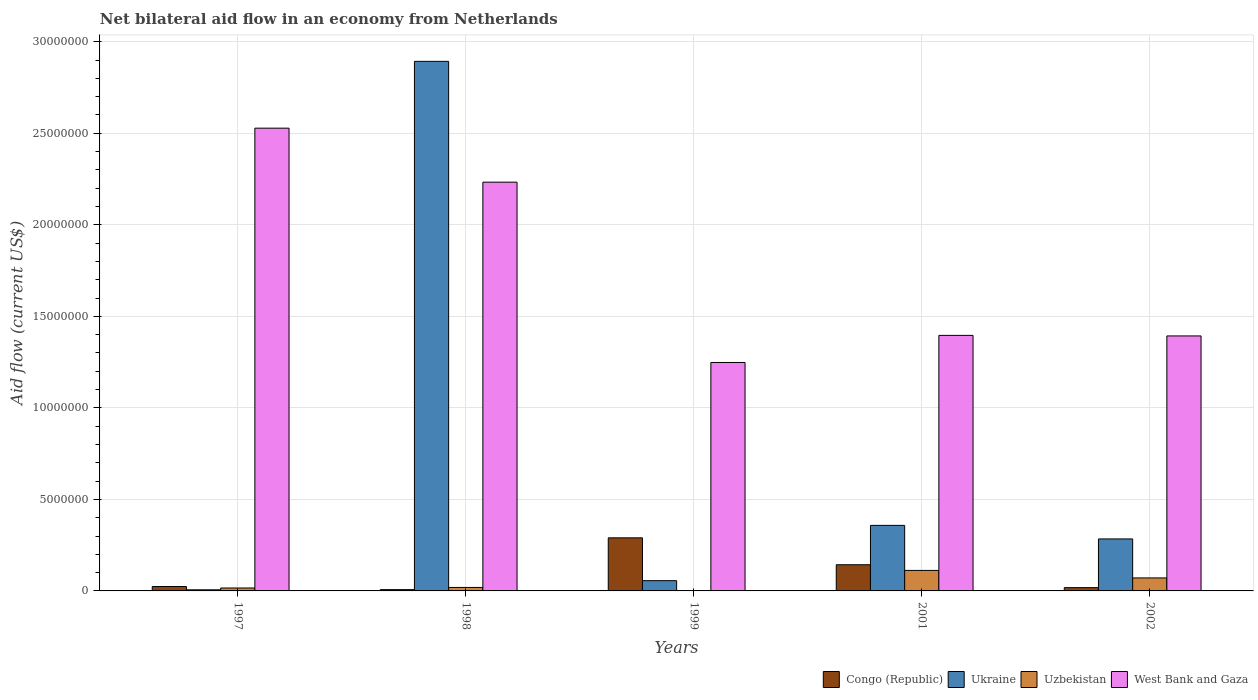How many different coloured bars are there?
Make the answer very short. 4. How many bars are there on the 1st tick from the left?
Provide a succinct answer. 4. How many bars are there on the 4th tick from the right?
Your answer should be very brief. 4. In how many cases, is the number of bars for a given year not equal to the number of legend labels?
Offer a terse response. 0. What is the net bilateral aid flow in West Bank and Gaza in 1998?
Give a very brief answer. 2.23e+07. Across all years, what is the maximum net bilateral aid flow in West Bank and Gaza?
Make the answer very short. 2.53e+07. In which year was the net bilateral aid flow in Ukraine maximum?
Provide a succinct answer. 1998. In which year was the net bilateral aid flow in Congo (Republic) minimum?
Give a very brief answer. 1998. What is the total net bilateral aid flow in Ukraine in the graph?
Your answer should be very brief. 3.60e+07. What is the difference between the net bilateral aid flow in Uzbekistan in 2001 and that in 2002?
Ensure brevity in your answer.  4.10e+05. What is the difference between the net bilateral aid flow in Congo (Republic) in 1998 and the net bilateral aid flow in Uzbekistan in 1999?
Give a very brief answer. 6.00e+04. What is the average net bilateral aid flow in Uzbekistan per year?
Make the answer very short. 4.38e+05. In the year 2002, what is the difference between the net bilateral aid flow in Ukraine and net bilateral aid flow in Congo (Republic)?
Offer a terse response. 2.66e+06. What is the ratio of the net bilateral aid flow in West Bank and Gaza in 1997 to that in 2001?
Offer a very short reply. 1.81. Is the difference between the net bilateral aid flow in Ukraine in 1998 and 1999 greater than the difference between the net bilateral aid flow in Congo (Republic) in 1998 and 1999?
Your answer should be very brief. Yes. What is the difference between the highest and the second highest net bilateral aid flow in Congo (Republic)?
Provide a short and direct response. 1.47e+06. What is the difference between the highest and the lowest net bilateral aid flow in Ukraine?
Ensure brevity in your answer.  2.89e+07. Is the sum of the net bilateral aid flow in Congo (Republic) in 1997 and 2002 greater than the maximum net bilateral aid flow in West Bank and Gaza across all years?
Keep it short and to the point. No. What does the 4th bar from the left in 1999 represents?
Offer a very short reply. West Bank and Gaza. What does the 4th bar from the right in 1997 represents?
Offer a very short reply. Congo (Republic). How many bars are there?
Ensure brevity in your answer.  20. Are all the bars in the graph horizontal?
Your answer should be very brief. No. How many years are there in the graph?
Provide a succinct answer. 5. Does the graph contain any zero values?
Make the answer very short. No. How many legend labels are there?
Offer a terse response. 4. What is the title of the graph?
Offer a terse response. Net bilateral aid flow in an economy from Netherlands. Does "Suriname" appear as one of the legend labels in the graph?
Offer a terse response. No. What is the label or title of the Y-axis?
Your answer should be very brief. Aid flow (current US$). What is the Aid flow (current US$) in Uzbekistan in 1997?
Offer a very short reply. 1.60e+05. What is the Aid flow (current US$) in West Bank and Gaza in 1997?
Provide a short and direct response. 2.53e+07. What is the Aid flow (current US$) of Congo (Republic) in 1998?
Your response must be concise. 7.00e+04. What is the Aid flow (current US$) of Ukraine in 1998?
Make the answer very short. 2.89e+07. What is the Aid flow (current US$) of West Bank and Gaza in 1998?
Provide a short and direct response. 2.23e+07. What is the Aid flow (current US$) in Congo (Republic) in 1999?
Offer a very short reply. 2.90e+06. What is the Aid flow (current US$) in Ukraine in 1999?
Make the answer very short. 5.60e+05. What is the Aid flow (current US$) of West Bank and Gaza in 1999?
Keep it short and to the point. 1.25e+07. What is the Aid flow (current US$) in Congo (Republic) in 2001?
Provide a succinct answer. 1.43e+06. What is the Aid flow (current US$) in Ukraine in 2001?
Your answer should be very brief. 3.58e+06. What is the Aid flow (current US$) of Uzbekistan in 2001?
Make the answer very short. 1.12e+06. What is the Aid flow (current US$) of West Bank and Gaza in 2001?
Your answer should be compact. 1.40e+07. What is the Aid flow (current US$) in Congo (Republic) in 2002?
Your response must be concise. 1.80e+05. What is the Aid flow (current US$) of Ukraine in 2002?
Ensure brevity in your answer.  2.84e+06. What is the Aid flow (current US$) in Uzbekistan in 2002?
Keep it short and to the point. 7.10e+05. What is the Aid flow (current US$) of West Bank and Gaza in 2002?
Offer a very short reply. 1.39e+07. Across all years, what is the maximum Aid flow (current US$) of Congo (Republic)?
Make the answer very short. 2.90e+06. Across all years, what is the maximum Aid flow (current US$) in Ukraine?
Your answer should be compact. 2.89e+07. Across all years, what is the maximum Aid flow (current US$) of Uzbekistan?
Keep it short and to the point. 1.12e+06. Across all years, what is the maximum Aid flow (current US$) of West Bank and Gaza?
Keep it short and to the point. 2.53e+07. Across all years, what is the minimum Aid flow (current US$) in Uzbekistan?
Your answer should be very brief. 10000. Across all years, what is the minimum Aid flow (current US$) in West Bank and Gaza?
Make the answer very short. 1.25e+07. What is the total Aid flow (current US$) in Congo (Republic) in the graph?
Your answer should be very brief. 4.82e+06. What is the total Aid flow (current US$) of Ukraine in the graph?
Provide a short and direct response. 3.60e+07. What is the total Aid flow (current US$) in Uzbekistan in the graph?
Provide a succinct answer. 2.19e+06. What is the total Aid flow (current US$) in West Bank and Gaza in the graph?
Ensure brevity in your answer.  8.80e+07. What is the difference between the Aid flow (current US$) in Ukraine in 1997 and that in 1998?
Ensure brevity in your answer.  -2.89e+07. What is the difference between the Aid flow (current US$) in Uzbekistan in 1997 and that in 1998?
Your answer should be compact. -3.00e+04. What is the difference between the Aid flow (current US$) of West Bank and Gaza in 1997 and that in 1998?
Your response must be concise. 2.95e+06. What is the difference between the Aid flow (current US$) of Congo (Republic) in 1997 and that in 1999?
Offer a terse response. -2.66e+06. What is the difference between the Aid flow (current US$) in Ukraine in 1997 and that in 1999?
Your answer should be compact. -5.00e+05. What is the difference between the Aid flow (current US$) in Uzbekistan in 1997 and that in 1999?
Your answer should be compact. 1.50e+05. What is the difference between the Aid flow (current US$) of West Bank and Gaza in 1997 and that in 1999?
Keep it short and to the point. 1.28e+07. What is the difference between the Aid flow (current US$) in Congo (Republic) in 1997 and that in 2001?
Your answer should be compact. -1.19e+06. What is the difference between the Aid flow (current US$) in Ukraine in 1997 and that in 2001?
Your response must be concise. -3.52e+06. What is the difference between the Aid flow (current US$) in Uzbekistan in 1997 and that in 2001?
Give a very brief answer. -9.60e+05. What is the difference between the Aid flow (current US$) of West Bank and Gaza in 1997 and that in 2001?
Your answer should be compact. 1.13e+07. What is the difference between the Aid flow (current US$) of Ukraine in 1997 and that in 2002?
Make the answer very short. -2.78e+06. What is the difference between the Aid flow (current US$) of Uzbekistan in 1997 and that in 2002?
Provide a short and direct response. -5.50e+05. What is the difference between the Aid flow (current US$) in West Bank and Gaza in 1997 and that in 2002?
Your answer should be compact. 1.14e+07. What is the difference between the Aid flow (current US$) in Congo (Republic) in 1998 and that in 1999?
Offer a terse response. -2.83e+06. What is the difference between the Aid flow (current US$) in Ukraine in 1998 and that in 1999?
Your response must be concise. 2.84e+07. What is the difference between the Aid flow (current US$) in Uzbekistan in 1998 and that in 1999?
Ensure brevity in your answer.  1.80e+05. What is the difference between the Aid flow (current US$) of West Bank and Gaza in 1998 and that in 1999?
Your answer should be compact. 9.85e+06. What is the difference between the Aid flow (current US$) of Congo (Republic) in 1998 and that in 2001?
Ensure brevity in your answer.  -1.36e+06. What is the difference between the Aid flow (current US$) of Ukraine in 1998 and that in 2001?
Make the answer very short. 2.54e+07. What is the difference between the Aid flow (current US$) of Uzbekistan in 1998 and that in 2001?
Your response must be concise. -9.30e+05. What is the difference between the Aid flow (current US$) in West Bank and Gaza in 1998 and that in 2001?
Keep it short and to the point. 8.37e+06. What is the difference between the Aid flow (current US$) of Ukraine in 1998 and that in 2002?
Offer a terse response. 2.61e+07. What is the difference between the Aid flow (current US$) in Uzbekistan in 1998 and that in 2002?
Make the answer very short. -5.20e+05. What is the difference between the Aid flow (current US$) of West Bank and Gaza in 1998 and that in 2002?
Give a very brief answer. 8.40e+06. What is the difference between the Aid flow (current US$) in Congo (Republic) in 1999 and that in 2001?
Provide a short and direct response. 1.47e+06. What is the difference between the Aid flow (current US$) in Ukraine in 1999 and that in 2001?
Provide a short and direct response. -3.02e+06. What is the difference between the Aid flow (current US$) in Uzbekistan in 1999 and that in 2001?
Keep it short and to the point. -1.11e+06. What is the difference between the Aid flow (current US$) in West Bank and Gaza in 1999 and that in 2001?
Make the answer very short. -1.48e+06. What is the difference between the Aid flow (current US$) in Congo (Republic) in 1999 and that in 2002?
Make the answer very short. 2.72e+06. What is the difference between the Aid flow (current US$) in Ukraine in 1999 and that in 2002?
Offer a very short reply. -2.28e+06. What is the difference between the Aid flow (current US$) of Uzbekistan in 1999 and that in 2002?
Offer a very short reply. -7.00e+05. What is the difference between the Aid flow (current US$) in West Bank and Gaza in 1999 and that in 2002?
Your answer should be compact. -1.45e+06. What is the difference between the Aid flow (current US$) in Congo (Republic) in 2001 and that in 2002?
Keep it short and to the point. 1.25e+06. What is the difference between the Aid flow (current US$) of Ukraine in 2001 and that in 2002?
Your response must be concise. 7.40e+05. What is the difference between the Aid flow (current US$) of West Bank and Gaza in 2001 and that in 2002?
Offer a terse response. 3.00e+04. What is the difference between the Aid flow (current US$) in Congo (Republic) in 1997 and the Aid flow (current US$) in Ukraine in 1998?
Give a very brief answer. -2.87e+07. What is the difference between the Aid flow (current US$) of Congo (Republic) in 1997 and the Aid flow (current US$) of Uzbekistan in 1998?
Offer a terse response. 5.00e+04. What is the difference between the Aid flow (current US$) of Congo (Republic) in 1997 and the Aid flow (current US$) of West Bank and Gaza in 1998?
Keep it short and to the point. -2.21e+07. What is the difference between the Aid flow (current US$) in Ukraine in 1997 and the Aid flow (current US$) in Uzbekistan in 1998?
Give a very brief answer. -1.30e+05. What is the difference between the Aid flow (current US$) in Ukraine in 1997 and the Aid flow (current US$) in West Bank and Gaza in 1998?
Provide a short and direct response. -2.23e+07. What is the difference between the Aid flow (current US$) of Uzbekistan in 1997 and the Aid flow (current US$) of West Bank and Gaza in 1998?
Offer a very short reply. -2.22e+07. What is the difference between the Aid flow (current US$) of Congo (Republic) in 1997 and the Aid flow (current US$) of Ukraine in 1999?
Offer a terse response. -3.20e+05. What is the difference between the Aid flow (current US$) in Congo (Republic) in 1997 and the Aid flow (current US$) in West Bank and Gaza in 1999?
Offer a terse response. -1.22e+07. What is the difference between the Aid flow (current US$) of Ukraine in 1997 and the Aid flow (current US$) of West Bank and Gaza in 1999?
Offer a very short reply. -1.24e+07. What is the difference between the Aid flow (current US$) in Uzbekistan in 1997 and the Aid flow (current US$) in West Bank and Gaza in 1999?
Offer a terse response. -1.23e+07. What is the difference between the Aid flow (current US$) in Congo (Republic) in 1997 and the Aid flow (current US$) in Ukraine in 2001?
Your answer should be compact. -3.34e+06. What is the difference between the Aid flow (current US$) of Congo (Republic) in 1997 and the Aid flow (current US$) of Uzbekistan in 2001?
Ensure brevity in your answer.  -8.80e+05. What is the difference between the Aid flow (current US$) of Congo (Republic) in 1997 and the Aid flow (current US$) of West Bank and Gaza in 2001?
Your answer should be very brief. -1.37e+07. What is the difference between the Aid flow (current US$) of Ukraine in 1997 and the Aid flow (current US$) of Uzbekistan in 2001?
Make the answer very short. -1.06e+06. What is the difference between the Aid flow (current US$) of Ukraine in 1997 and the Aid flow (current US$) of West Bank and Gaza in 2001?
Your answer should be compact. -1.39e+07. What is the difference between the Aid flow (current US$) in Uzbekistan in 1997 and the Aid flow (current US$) in West Bank and Gaza in 2001?
Your response must be concise. -1.38e+07. What is the difference between the Aid flow (current US$) of Congo (Republic) in 1997 and the Aid flow (current US$) of Ukraine in 2002?
Offer a very short reply. -2.60e+06. What is the difference between the Aid flow (current US$) in Congo (Republic) in 1997 and the Aid flow (current US$) in Uzbekistan in 2002?
Your answer should be very brief. -4.70e+05. What is the difference between the Aid flow (current US$) in Congo (Republic) in 1997 and the Aid flow (current US$) in West Bank and Gaza in 2002?
Make the answer very short. -1.37e+07. What is the difference between the Aid flow (current US$) in Ukraine in 1997 and the Aid flow (current US$) in Uzbekistan in 2002?
Offer a very short reply. -6.50e+05. What is the difference between the Aid flow (current US$) in Ukraine in 1997 and the Aid flow (current US$) in West Bank and Gaza in 2002?
Keep it short and to the point. -1.39e+07. What is the difference between the Aid flow (current US$) of Uzbekistan in 1997 and the Aid flow (current US$) of West Bank and Gaza in 2002?
Provide a short and direct response. -1.38e+07. What is the difference between the Aid flow (current US$) of Congo (Republic) in 1998 and the Aid flow (current US$) of Ukraine in 1999?
Your response must be concise. -4.90e+05. What is the difference between the Aid flow (current US$) of Congo (Republic) in 1998 and the Aid flow (current US$) of West Bank and Gaza in 1999?
Offer a terse response. -1.24e+07. What is the difference between the Aid flow (current US$) of Ukraine in 1998 and the Aid flow (current US$) of Uzbekistan in 1999?
Your response must be concise. 2.89e+07. What is the difference between the Aid flow (current US$) in Ukraine in 1998 and the Aid flow (current US$) in West Bank and Gaza in 1999?
Keep it short and to the point. 1.64e+07. What is the difference between the Aid flow (current US$) of Uzbekistan in 1998 and the Aid flow (current US$) of West Bank and Gaza in 1999?
Your response must be concise. -1.23e+07. What is the difference between the Aid flow (current US$) in Congo (Republic) in 1998 and the Aid flow (current US$) in Ukraine in 2001?
Provide a succinct answer. -3.51e+06. What is the difference between the Aid flow (current US$) in Congo (Republic) in 1998 and the Aid flow (current US$) in Uzbekistan in 2001?
Ensure brevity in your answer.  -1.05e+06. What is the difference between the Aid flow (current US$) in Congo (Republic) in 1998 and the Aid flow (current US$) in West Bank and Gaza in 2001?
Offer a terse response. -1.39e+07. What is the difference between the Aid flow (current US$) of Ukraine in 1998 and the Aid flow (current US$) of Uzbekistan in 2001?
Offer a terse response. 2.78e+07. What is the difference between the Aid flow (current US$) of Ukraine in 1998 and the Aid flow (current US$) of West Bank and Gaza in 2001?
Provide a short and direct response. 1.50e+07. What is the difference between the Aid flow (current US$) of Uzbekistan in 1998 and the Aid flow (current US$) of West Bank and Gaza in 2001?
Make the answer very short. -1.38e+07. What is the difference between the Aid flow (current US$) of Congo (Republic) in 1998 and the Aid flow (current US$) of Ukraine in 2002?
Your response must be concise. -2.77e+06. What is the difference between the Aid flow (current US$) in Congo (Republic) in 1998 and the Aid flow (current US$) in Uzbekistan in 2002?
Provide a succinct answer. -6.40e+05. What is the difference between the Aid flow (current US$) of Congo (Republic) in 1998 and the Aid flow (current US$) of West Bank and Gaza in 2002?
Offer a terse response. -1.39e+07. What is the difference between the Aid flow (current US$) of Ukraine in 1998 and the Aid flow (current US$) of Uzbekistan in 2002?
Provide a succinct answer. 2.82e+07. What is the difference between the Aid flow (current US$) of Ukraine in 1998 and the Aid flow (current US$) of West Bank and Gaza in 2002?
Your answer should be very brief. 1.50e+07. What is the difference between the Aid flow (current US$) of Uzbekistan in 1998 and the Aid flow (current US$) of West Bank and Gaza in 2002?
Make the answer very short. -1.37e+07. What is the difference between the Aid flow (current US$) of Congo (Republic) in 1999 and the Aid flow (current US$) of Ukraine in 2001?
Provide a short and direct response. -6.80e+05. What is the difference between the Aid flow (current US$) in Congo (Republic) in 1999 and the Aid flow (current US$) in Uzbekistan in 2001?
Ensure brevity in your answer.  1.78e+06. What is the difference between the Aid flow (current US$) in Congo (Republic) in 1999 and the Aid flow (current US$) in West Bank and Gaza in 2001?
Provide a short and direct response. -1.11e+07. What is the difference between the Aid flow (current US$) of Ukraine in 1999 and the Aid flow (current US$) of Uzbekistan in 2001?
Make the answer very short. -5.60e+05. What is the difference between the Aid flow (current US$) of Ukraine in 1999 and the Aid flow (current US$) of West Bank and Gaza in 2001?
Provide a short and direct response. -1.34e+07. What is the difference between the Aid flow (current US$) in Uzbekistan in 1999 and the Aid flow (current US$) in West Bank and Gaza in 2001?
Make the answer very short. -1.40e+07. What is the difference between the Aid flow (current US$) of Congo (Republic) in 1999 and the Aid flow (current US$) of Ukraine in 2002?
Make the answer very short. 6.00e+04. What is the difference between the Aid flow (current US$) of Congo (Republic) in 1999 and the Aid flow (current US$) of Uzbekistan in 2002?
Provide a succinct answer. 2.19e+06. What is the difference between the Aid flow (current US$) of Congo (Republic) in 1999 and the Aid flow (current US$) of West Bank and Gaza in 2002?
Keep it short and to the point. -1.10e+07. What is the difference between the Aid flow (current US$) in Ukraine in 1999 and the Aid flow (current US$) in Uzbekistan in 2002?
Your answer should be very brief. -1.50e+05. What is the difference between the Aid flow (current US$) of Ukraine in 1999 and the Aid flow (current US$) of West Bank and Gaza in 2002?
Your response must be concise. -1.34e+07. What is the difference between the Aid flow (current US$) of Uzbekistan in 1999 and the Aid flow (current US$) of West Bank and Gaza in 2002?
Ensure brevity in your answer.  -1.39e+07. What is the difference between the Aid flow (current US$) in Congo (Republic) in 2001 and the Aid flow (current US$) in Ukraine in 2002?
Provide a succinct answer. -1.41e+06. What is the difference between the Aid flow (current US$) of Congo (Republic) in 2001 and the Aid flow (current US$) of Uzbekistan in 2002?
Provide a succinct answer. 7.20e+05. What is the difference between the Aid flow (current US$) in Congo (Republic) in 2001 and the Aid flow (current US$) in West Bank and Gaza in 2002?
Give a very brief answer. -1.25e+07. What is the difference between the Aid flow (current US$) of Ukraine in 2001 and the Aid flow (current US$) of Uzbekistan in 2002?
Offer a very short reply. 2.87e+06. What is the difference between the Aid flow (current US$) of Ukraine in 2001 and the Aid flow (current US$) of West Bank and Gaza in 2002?
Offer a very short reply. -1.04e+07. What is the difference between the Aid flow (current US$) of Uzbekistan in 2001 and the Aid flow (current US$) of West Bank and Gaza in 2002?
Provide a succinct answer. -1.28e+07. What is the average Aid flow (current US$) of Congo (Republic) per year?
Make the answer very short. 9.64e+05. What is the average Aid flow (current US$) of Ukraine per year?
Provide a succinct answer. 7.19e+06. What is the average Aid flow (current US$) in Uzbekistan per year?
Your answer should be compact. 4.38e+05. What is the average Aid flow (current US$) of West Bank and Gaza per year?
Your response must be concise. 1.76e+07. In the year 1997, what is the difference between the Aid flow (current US$) of Congo (Republic) and Aid flow (current US$) of West Bank and Gaza?
Your response must be concise. -2.50e+07. In the year 1997, what is the difference between the Aid flow (current US$) in Ukraine and Aid flow (current US$) in West Bank and Gaza?
Your answer should be very brief. -2.52e+07. In the year 1997, what is the difference between the Aid flow (current US$) of Uzbekistan and Aid flow (current US$) of West Bank and Gaza?
Your answer should be compact. -2.51e+07. In the year 1998, what is the difference between the Aid flow (current US$) of Congo (Republic) and Aid flow (current US$) of Ukraine?
Ensure brevity in your answer.  -2.89e+07. In the year 1998, what is the difference between the Aid flow (current US$) in Congo (Republic) and Aid flow (current US$) in West Bank and Gaza?
Your answer should be compact. -2.23e+07. In the year 1998, what is the difference between the Aid flow (current US$) in Ukraine and Aid flow (current US$) in Uzbekistan?
Give a very brief answer. 2.87e+07. In the year 1998, what is the difference between the Aid flow (current US$) in Ukraine and Aid flow (current US$) in West Bank and Gaza?
Your answer should be compact. 6.60e+06. In the year 1998, what is the difference between the Aid flow (current US$) of Uzbekistan and Aid flow (current US$) of West Bank and Gaza?
Make the answer very short. -2.21e+07. In the year 1999, what is the difference between the Aid flow (current US$) of Congo (Republic) and Aid flow (current US$) of Ukraine?
Give a very brief answer. 2.34e+06. In the year 1999, what is the difference between the Aid flow (current US$) of Congo (Republic) and Aid flow (current US$) of Uzbekistan?
Make the answer very short. 2.89e+06. In the year 1999, what is the difference between the Aid flow (current US$) in Congo (Republic) and Aid flow (current US$) in West Bank and Gaza?
Give a very brief answer. -9.58e+06. In the year 1999, what is the difference between the Aid flow (current US$) of Ukraine and Aid flow (current US$) of Uzbekistan?
Provide a short and direct response. 5.50e+05. In the year 1999, what is the difference between the Aid flow (current US$) of Ukraine and Aid flow (current US$) of West Bank and Gaza?
Provide a short and direct response. -1.19e+07. In the year 1999, what is the difference between the Aid flow (current US$) in Uzbekistan and Aid flow (current US$) in West Bank and Gaza?
Your response must be concise. -1.25e+07. In the year 2001, what is the difference between the Aid flow (current US$) of Congo (Republic) and Aid flow (current US$) of Ukraine?
Offer a terse response. -2.15e+06. In the year 2001, what is the difference between the Aid flow (current US$) in Congo (Republic) and Aid flow (current US$) in West Bank and Gaza?
Offer a very short reply. -1.25e+07. In the year 2001, what is the difference between the Aid flow (current US$) in Ukraine and Aid flow (current US$) in Uzbekistan?
Your answer should be very brief. 2.46e+06. In the year 2001, what is the difference between the Aid flow (current US$) of Ukraine and Aid flow (current US$) of West Bank and Gaza?
Your answer should be compact. -1.04e+07. In the year 2001, what is the difference between the Aid flow (current US$) of Uzbekistan and Aid flow (current US$) of West Bank and Gaza?
Your answer should be compact. -1.28e+07. In the year 2002, what is the difference between the Aid flow (current US$) in Congo (Republic) and Aid flow (current US$) in Ukraine?
Your answer should be very brief. -2.66e+06. In the year 2002, what is the difference between the Aid flow (current US$) in Congo (Republic) and Aid flow (current US$) in Uzbekistan?
Your answer should be compact. -5.30e+05. In the year 2002, what is the difference between the Aid flow (current US$) of Congo (Republic) and Aid flow (current US$) of West Bank and Gaza?
Provide a short and direct response. -1.38e+07. In the year 2002, what is the difference between the Aid flow (current US$) in Ukraine and Aid flow (current US$) in Uzbekistan?
Make the answer very short. 2.13e+06. In the year 2002, what is the difference between the Aid flow (current US$) of Ukraine and Aid flow (current US$) of West Bank and Gaza?
Offer a very short reply. -1.11e+07. In the year 2002, what is the difference between the Aid flow (current US$) in Uzbekistan and Aid flow (current US$) in West Bank and Gaza?
Provide a short and direct response. -1.32e+07. What is the ratio of the Aid flow (current US$) in Congo (Republic) in 1997 to that in 1998?
Ensure brevity in your answer.  3.43. What is the ratio of the Aid flow (current US$) of Ukraine in 1997 to that in 1998?
Provide a succinct answer. 0. What is the ratio of the Aid flow (current US$) in Uzbekistan in 1997 to that in 1998?
Your response must be concise. 0.84. What is the ratio of the Aid flow (current US$) of West Bank and Gaza in 1997 to that in 1998?
Keep it short and to the point. 1.13. What is the ratio of the Aid flow (current US$) of Congo (Republic) in 1997 to that in 1999?
Your answer should be very brief. 0.08. What is the ratio of the Aid flow (current US$) of Ukraine in 1997 to that in 1999?
Offer a very short reply. 0.11. What is the ratio of the Aid flow (current US$) in West Bank and Gaza in 1997 to that in 1999?
Your response must be concise. 2.03. What is the ratio of the Aid flow (current US$) of Congo (Republic) in 1997 to that in 2001?
Your answer should be very brief. 0.17. What is the ratio of the Aid flow (current US$) in Ukraine in 1997 to that in 2001?
Ensure brevity in your answer.  0.02. What is the ratio of the Aid flow (current US$) in Uzbekistan in 1997 to that in 2001?
Offer a terse response. 0.14. What is the ratio of the Aid flow (current US$) of West Bank and Gaza in 1997 to that in 2001?
Provide a succinct answer. 1.81. What is the ratio of the Aid flow (current US$) in Ukraine in 1997 to that in 2002?
Your response must be concise. 0.02. What is the ratio of the Aid flow (current US$) of Uzbekistan in 1997 to that in 2002?
Your answer should be compact. 0.23. What is the ratio of the Aid flow (current US$) in West Bank and Gaza in 1997 to that in 2002?
Your answer should be compact. 1.81. What is the ratio of the Aid flow (current US$) of Congo (Republic) in 1998 to that in 1999?
Offer a very short reply. 0.02. What is the ratio of the Aid flow (current US$) of Ukraine in 1998 to that in 1999?
Ensure brevity in your answer.  51.66. What is the ratio of the Aid flow (current US$) of Uzbekistan in 1998 to that in 1999?
Your answer should be compact. 19. What is the ratio of the Aid flow (current US$) in West Bank and Gaza in 1998 to that in 1999?
Make the answer very short. 1.79. What is the ratio of the Aid flow (current US$) of Congo (Republic) in 1998 to that in 2001?
Keep it short and to the point. 0.05. What is the ratio of the Aid flow (current US$) in Ukraine in 1998 to that in 2001?
Offer a terse response. 8.08. What is the ratio of the Aid flow (current US$) of Uzbekistan in 1998 to that in 2001?
Offer a very short reply. 0.17. What is the ratio of the Aid flow (current US$) in West Bank and Gaza in 1998 to that in 2001?
Your response must be concise. 1.6. What is the ratio of the Aid flow (current US$) in Congo (Republic) in 1998 to that in 2002?
Provide a succinct answer. 0.39. What is the ratio of the Aid flow (current US$) of Ukraine in 1998 to that in 2002?
Your answer should be very brief. 10.19. What is the ratio of the Aid flow (current US$) of Uzbekistan in 1998 to that in 2002?
Your response must be concise. 0.27. What is the ratio of the Aid flow (current US$) in West Bank and Gaza in 1998 to that in 2002?
Your response must be concise. 1.6. What is the ratio of the Aid flow (current US$) of Congo (Republic) in 1999 to that in 2001?
Offer a very short reply. 2.03. What is the ratio of the Aid flow (current US$) in Ukraine in 1999 to that in 2001?
Provide a succinct answer. 0.16. What is the ratio of the Aid flow (current US$) of Uzbekistan in 1999 to that in 2001?
Offer a terse response. 0.01. What is the ratio of the Aid flow (current US$) of West Bank and Gaza in 1999 to that in 2001?
Keep it short and to the point. 0.89. What is the ratio of the Aid flow (current US$) in Congo (Republic) in 1999 to that in 2002?
Provide a succinct answer. 16.11. What is the ratio of the Aid flow (current US$) of Ukraine in 1999 to that in 2002?
Ensure brevity in your answer.  0.2. What is the ratio of the Aid flow (current US$) of Uzbekistan in 1999 to that in 2002?
Your answer should be compact. 0.01. What is the ratio of the Aid flow (current US$) in West Bank and Gaza in 1999 to that in 2002?
Ensure brevity in your answer.  0.9. What is the ratio of the Aid flow (current US$) in Congo (Republic) in 2001 to that in 2002?
Provide a succinct answer. 7.94. What is the ratio of the Aid flow (current US$) of Ukraine in 2001 to that in 2002?
Offer a terse response. 1.26. What is the ratio of the Aid flow (current US$) in Uzbekistan in 2001 to that in 2002?
Make the answer very short. 1.58. What is the ratio of the Aid flow (current US$) of West Bank and Gaza in 2001 to that in 2002?
Offer a very short reply. 1. What is the difference between the highest and the second highest Aid flow (current US$) of Congo (Republic)?
Your response must be concise. 1.47e+06. What is the difference between the highest and the second highest Aid flow (current US$) of Ukraine?
Keep it short and to the point. 2.54e+07. What is the difference between the highest and the second highest Aid flow (current US$) in West Bank and Gaza?
Your answer should be very brief. 2.95e+06. What is the difference between the highest and the lowest Aid flow (current US$) of Congo (Republic)?
Keep it short and to the point. 2.83e+06. What is the difference between the highest and the lowest Aid flow (current US$) of Ukraine?
Provide a short and direct response. 2.89e+07. What is the difference between the highest and the lowest Aid flow (current US$) in Uzbekistan?
Your response must be concise. 1.11e+06. What is the difference between the highest and the lowest Aid flow (current US$) in West Bank and Gaza?
Offer a terse response. 1.28e+07. 